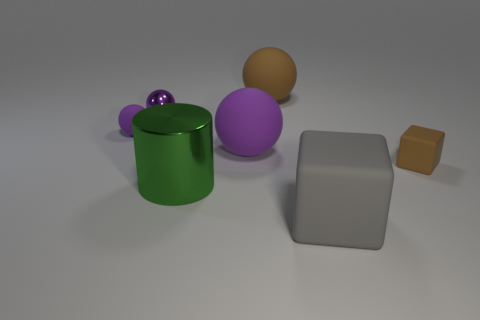Subtract all green cubes. How many purple spheres are left? 3 Subtract all yellow balls. Subtract all yellow cylinders. How many balls are left? 4 Add 1 large purple rubber spheres. How many objects exist? 8 Subtract all cubes. How many objects are left? 5 Subtract all small purple shiny spheres. Subtract all gray blocks. How many objects are left? 5 Add 2 tiny purple rubber things. How many tiny purple rubber things are left? 3 Add 1 matte things. How many matte things exist? 6 Subtract 2 purple spheres. How many objects are left? 5 